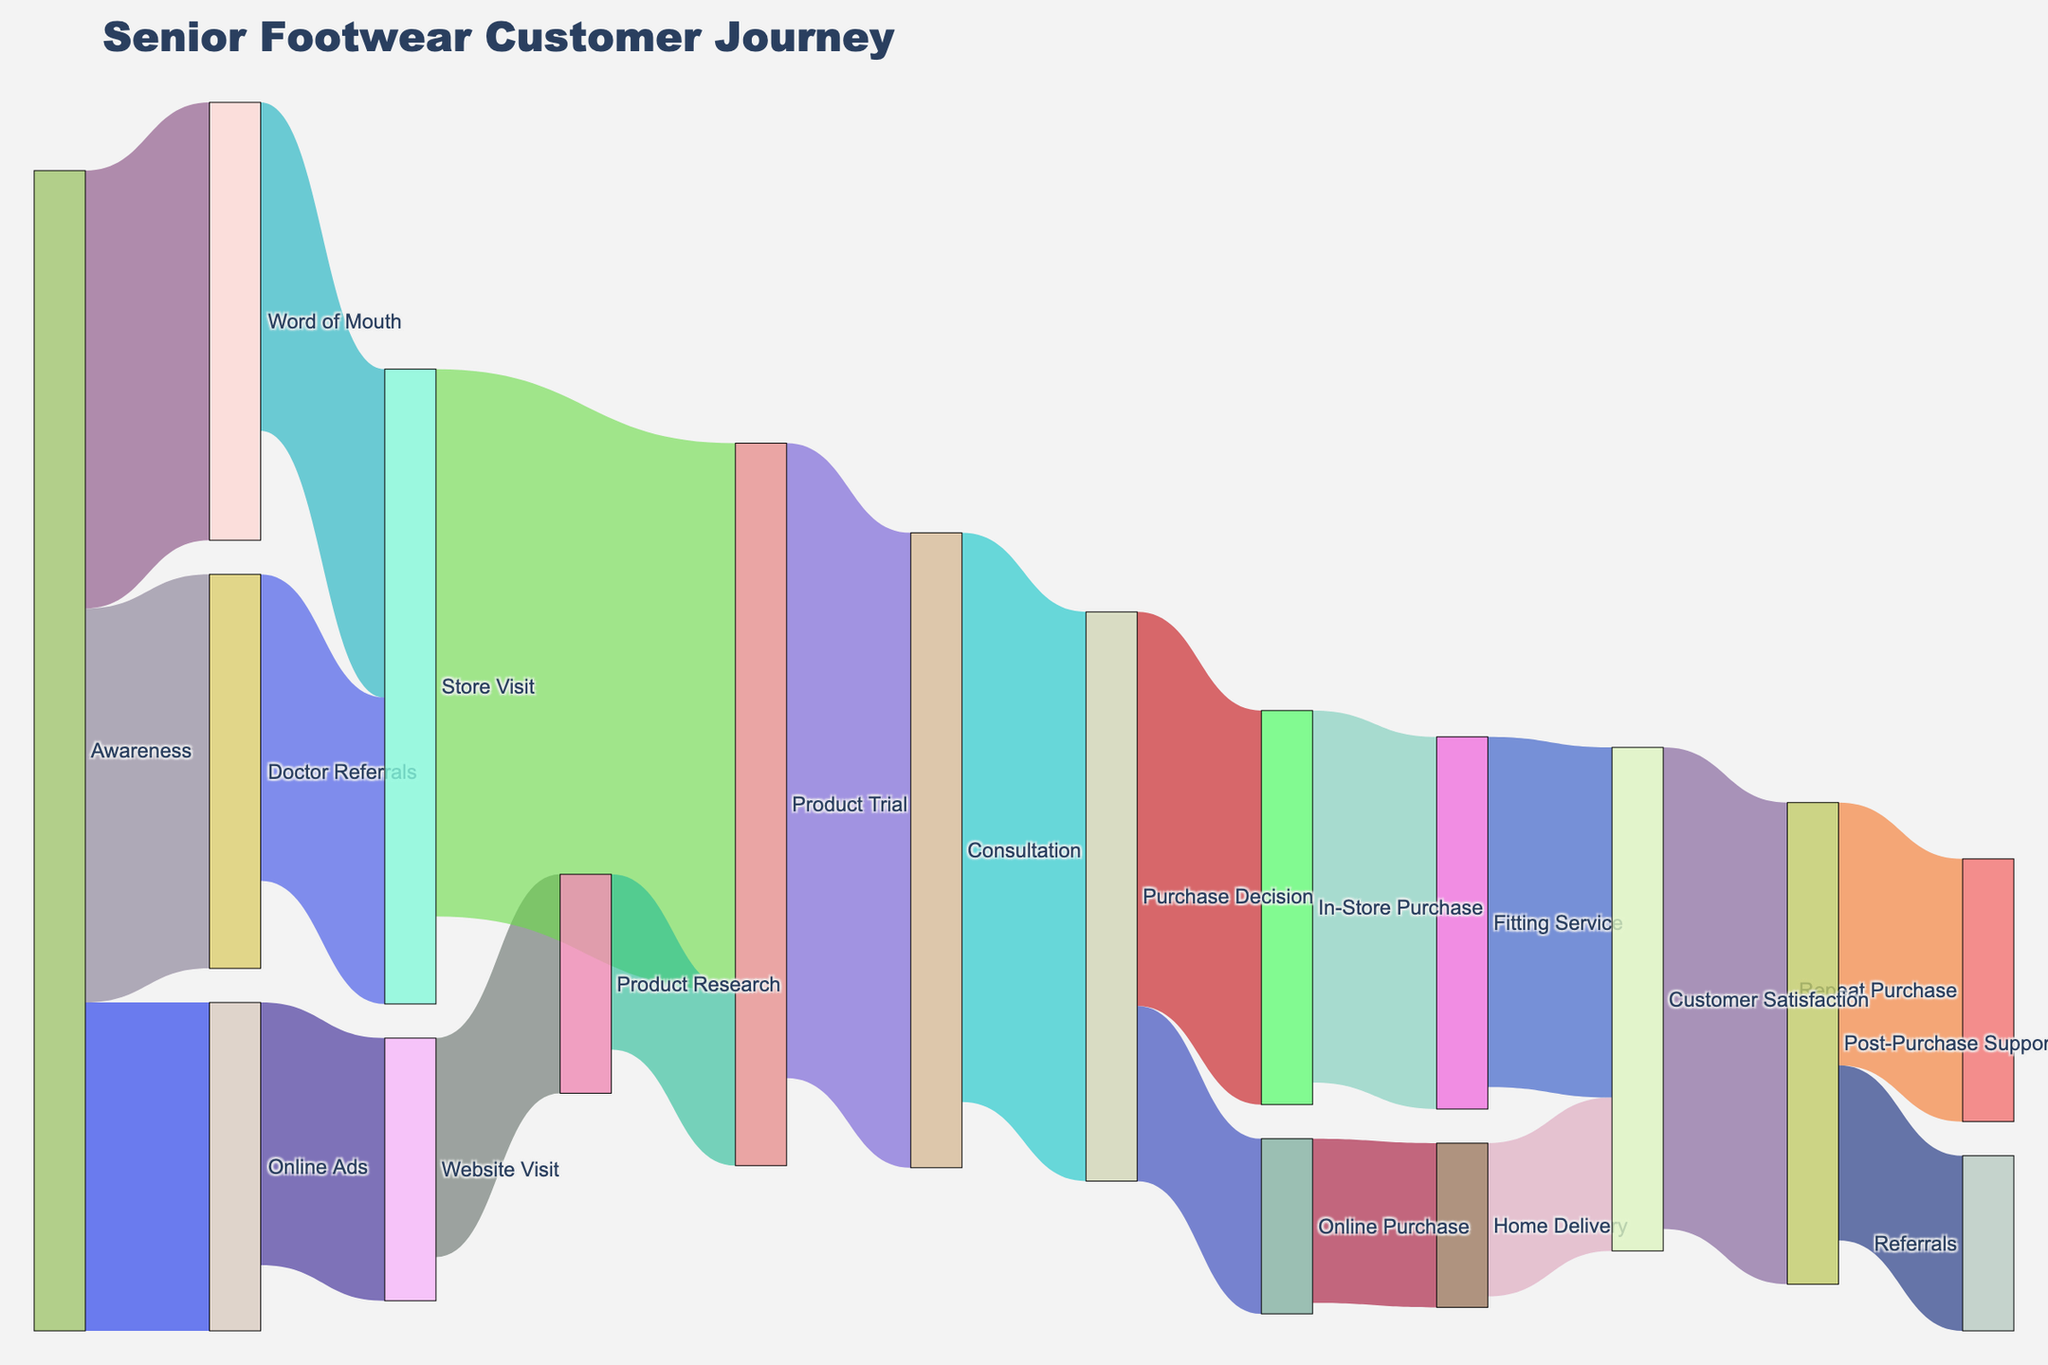Which source has the highest number of initial awareness? From the figure, the initial awareness sources are Online Ads, Word of Mouth, and Doctor Referrals. Comparing the values, Word of Mouth (200) has the highest number.
Answer: Word of Mouth How many customers visited the store directly from awareness channels? Adding the values of customers coming directly from Word of Mouth (150) and Doctor Referrals (140) gives 150 + 140 = 290.
Answer: 290 What is the total number of customers who made a product trial? Combining those who came through Website Visit (80) and Store Visit (250) gives 80 + 250 = 330.
Answer: 330 Compare the number of customers who made an In-Store Purchase to those who made an Online Purchase. From the Purchase Decision, 180 customers made an In-Store Purchase, and 80 made an Online Purchase. There are more In-Store Purchases than Online Purchases.
Answer: In-Store Purchase What percentage of customers achieved Customer Satisfaction through Fitting Service out of the total who made In-Store Purchase? Out of 180 In-Store Purchases, 170 achieved Customer Satisfaction through Fitting Service. (170/180) * 100 = 94.44%.
Answer: 94.44% Which path leads to the Post-Purchase Support stage, and what are the respective numbers? The paths leading to Post-Purchase Support are from Customer Satisfaction, with the values 160 (Fitting Service) + 70 (Home Delivery) = 230.
Answer: 230 How many repeat purchases were made? The Repeat Purchase is given directly in the Post-Purchase Support stage, with a value of 120.
Answer: 120 Which post-purchase support channel leads to the most customer satisfaction? Fitting Service leads to 160 Customer Satisfaction, whereas Home Delivery leads to 70. Fitting Service leads to more satisfaction.
Answer: Fitting Service 